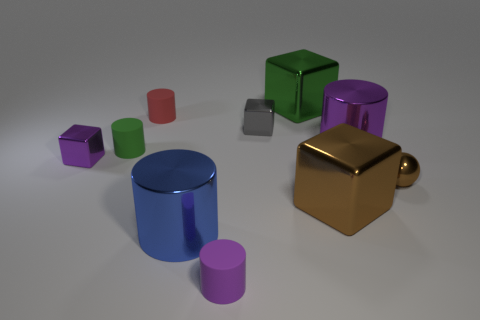Can you identify any patterns or symmetry in the arrangement of objects? The objects are arranged in an asymmetrical but balanced composition. There are no apparent repeating patterns, but there is a sense of order, as objects are evenly spaced and grouped by size and shape to some extent, creating a harmonious visual appeal. 